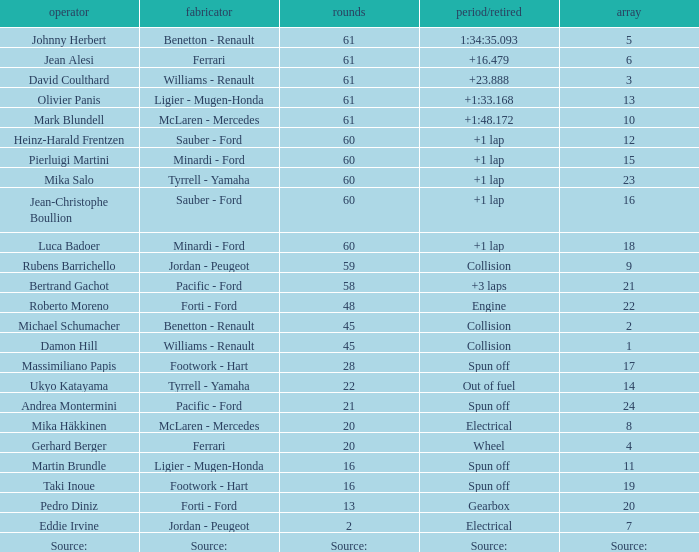How many laps does luca badoer have? 60.0. 